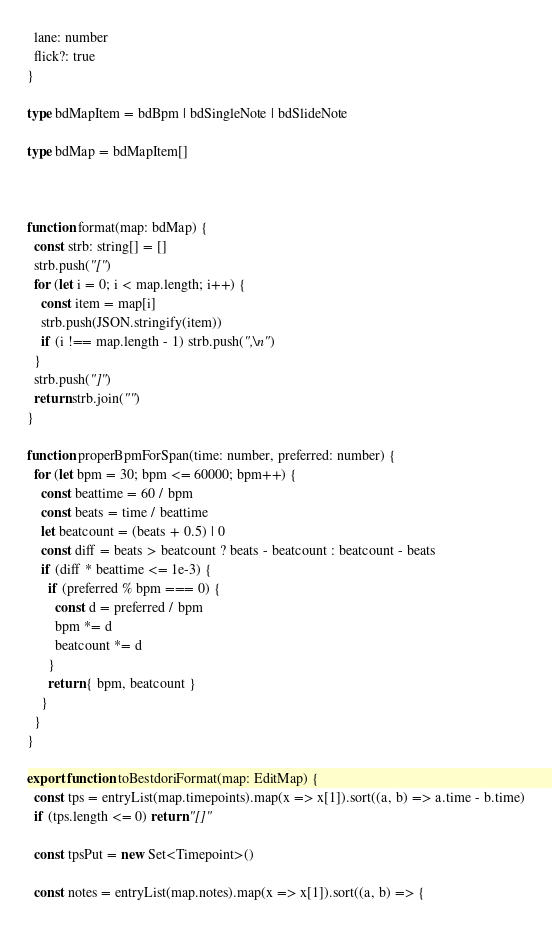Convert code to text. <code><loc_0><loc_0><loc_500><loc_500><_TypeScript_>  lane: number
  flick?: true
}

type bdMapItem = bdBpm | bdSingleNote | bdSlideNote

type bdMap = bdMapItem[]



function format(map: bdMap) {
  const strb: string[] = []
  strb.push("[")
  for (let i = 0; i < map.length; i++) {
    const item = map[i]
    strb.push(JSON.stringify(item))
    if (i !== map.length - 1) strb.push(",\n")
  }
  strb.push("]")
  return strb.join("")
}

function properBpmForSpan(time: number, preferred: number) {
  for (let bpm = 30; bpm <= 60000; bpm++) {
    const beattime = 60 / bpm
    const beats = time / beattime
    let beatcount = (beats + 0.5) | 0
    const diff = beats > beatcount ? beats - beatcount : beatcount - beats
    if (diff * beattime <= 1e-3) {
      if (preferred % bpm === 0) {
        const d = preferred / bpm
        bpm *= d
        beatcount *= d
      }
      return { bpm, beatcount }
    }
  }
}

export function toBestdoriFormat(map: EditMap) {
  const tps = entryList(map.timepoints).map(x => x[1]).sort((a, b) => a.time - b.time)
  if (tps.length <= 0) return "[]"

  const tpsPut = new Set<Timepoint>()

  const notes = entryList(map.notes).map(x => x[1]).sort((a, b) => {</code> 